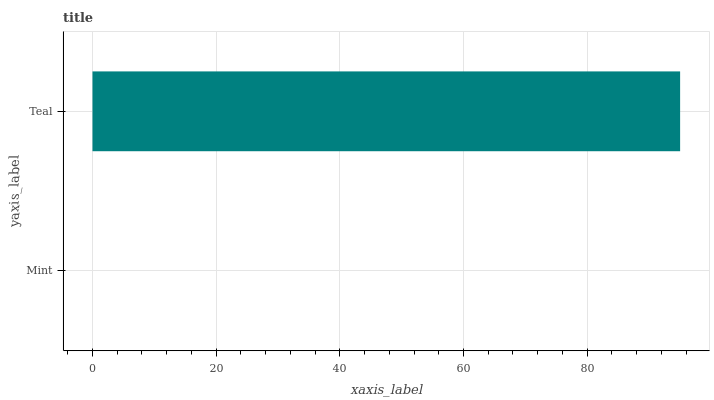Is Mint the minimum?
Answer yes or no. Yes. Is Teal the maximum?
Answer yes or no. Yes. Is Teal the minimum?
Answer yes or no. No. Is Teal greater than Mint?
Answer yes or no. Yes. Is Mint less than Teal?
Answer yes or no. Yes. Is Mint greater than Teal?
Answer yes or no. No. Is Teal less than Mint?
Answer yes or no. No. Is Teal the high median?
Answer yes or no. Yes. Is Mint the low median?
Answer yes or no. Yes. Is Mint the high median?
Answer yes or no. No. Is Teal the low median?
Answer yes or no. No. 